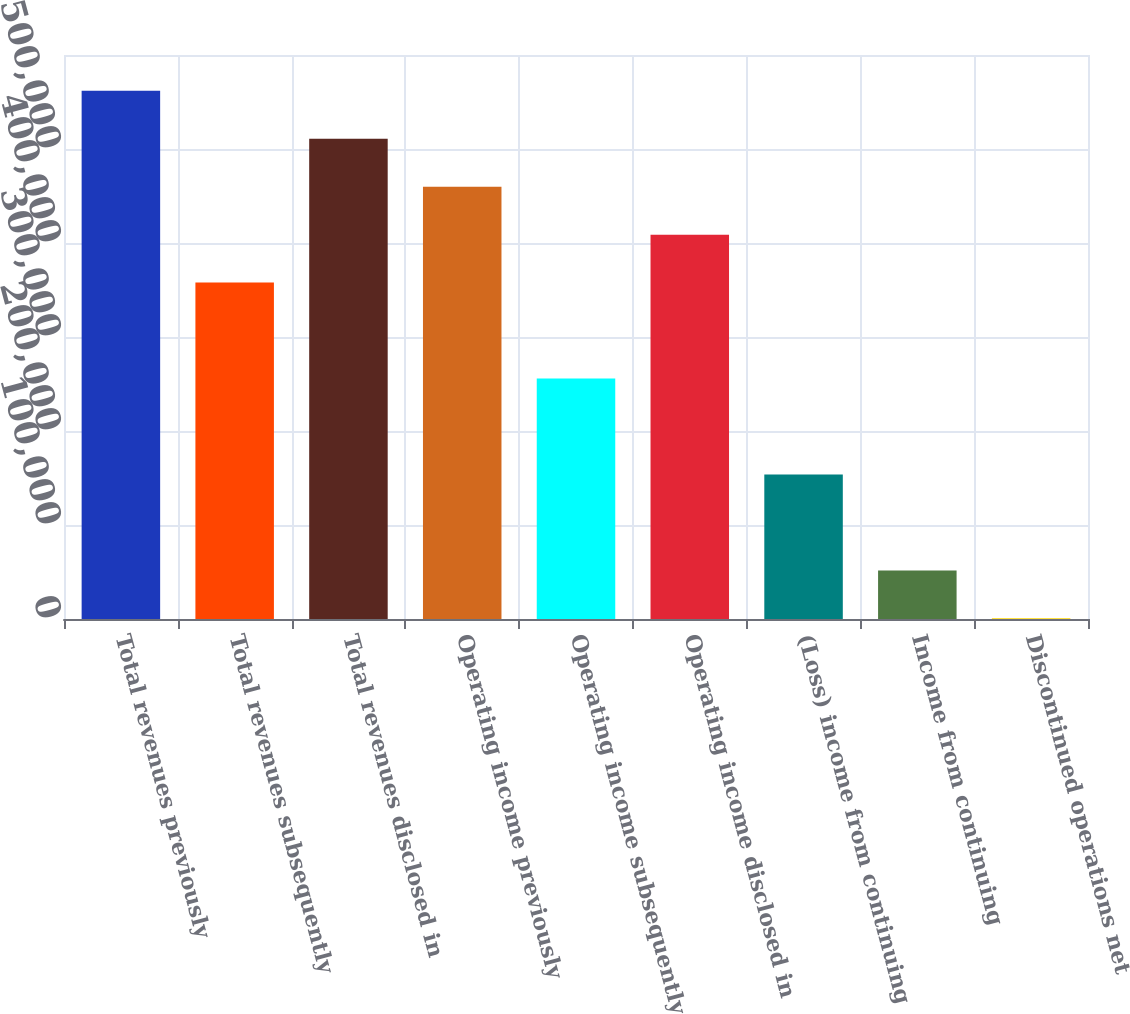Convert chart to OTSL. <chart><loc_0><loc_0><loc_500><loc_500><bar_chart><fcel>Total revenues previously<fcel>Total revenues subsequently<fcel>Total revenues disclosed in<fcel>Operating income previously<fcel>Operating income subsequently<fcel>Operating income disclosed in<fcel>(Loss) income from continuing<fcel>Income from continuing<fcel>Discontinued operations net<nl><fcel>561962<fcel>357861<fcel>510937<fcel>459912<fcel>255810<fcel>408886<fcel>153759<fcel>51708.4<fcel>683<nl></chart> 